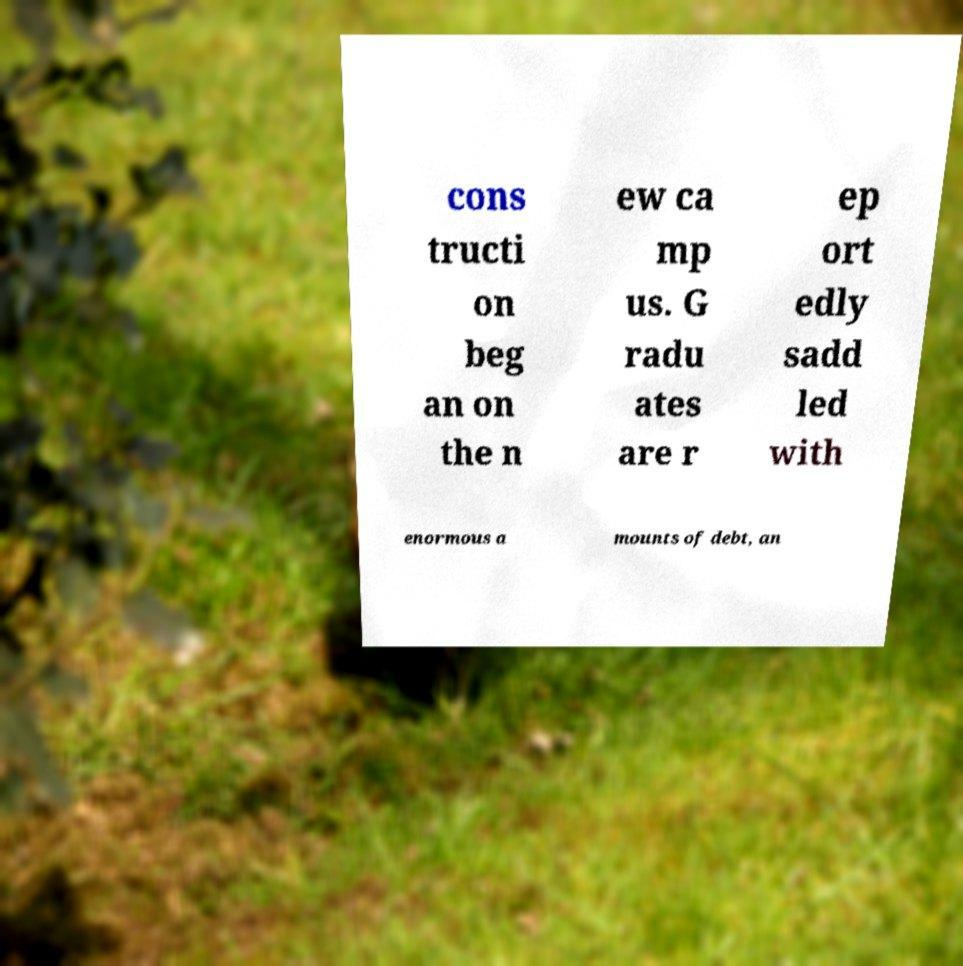There's text embedded in this image that I need extracted. Can you transcribe it verbatim? cons tructi on beg an on the n ew ca mp us. G radu ates are r ep ort edly sadd led with enormous a mounts of debt, an 